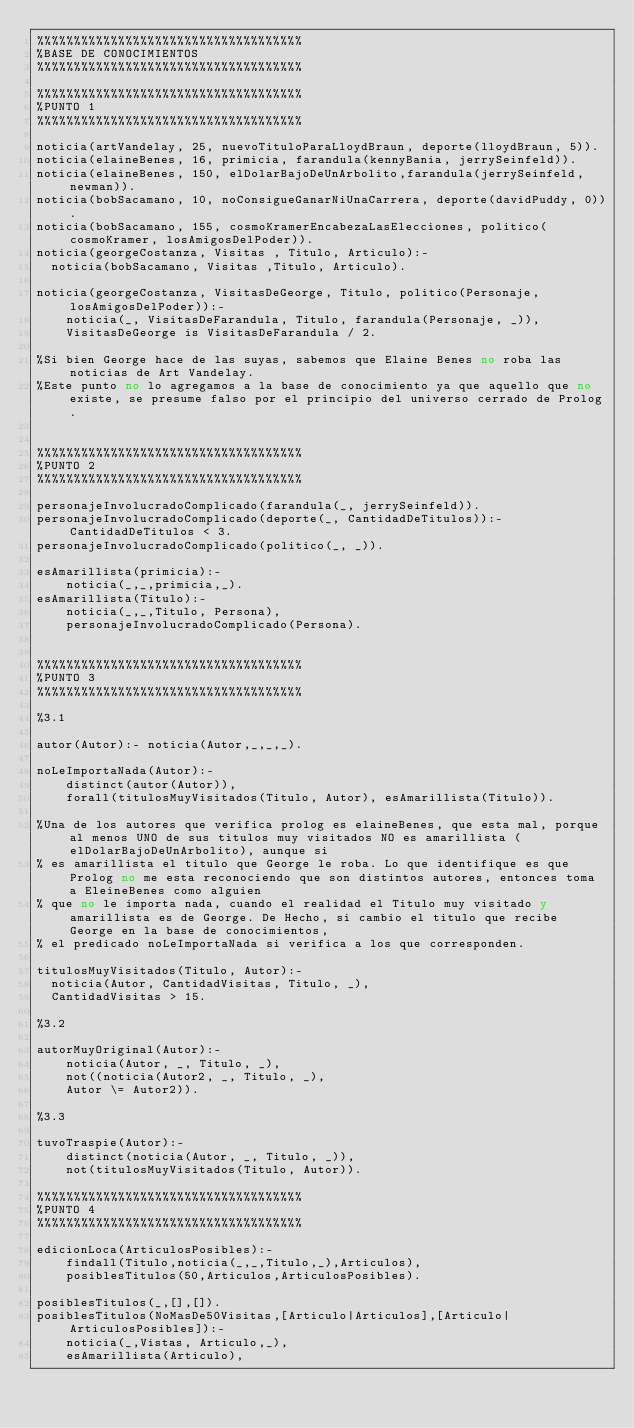<code> <loc_0><loc_0><loc_500><loc_500><_Perl_>%%%%%%%%%%%%%%%%%%%%%%%%%%%%%%%%%%%%
%BASE DE CONOCIMIENTOS
%%%%%%%%%%%%%%%%%%%%%%%%%%%%%%%%%%%%

%%%%%%%%%%%%%%%%%%%%%%%%%%%%%%%%%%%%
%PUNTO 1
%%%%%%%%%%%%%%%%%%%%%%%%%%%%%%%%%%%%

noticia(artVandelay, 25, nuevoTituloParaLloydBraun, deporte(lloydBraun, 5)).
noticia(elaineBenes, 16, primicia, farandula(kennyBania, jerrySeinfeld)).
noticia(elaineBenes, 150, elDolarBajoDeUnArbolito,farandula(jerrySeinfeld, newman)).
noticia(bobSacamano, 10, noConsigueGanarNiUnaCarrera, deporte(davidPuddy, 0)).
noticia(bobSacamano, 155, cosmoKramerEncabezaLasElecciones, politico(cosmoKramer, losAmigosDelPoder)).
noticia(georgeCostanza, Visitas , Titulo, Articulo):- 
  noticia(bobSacamano, Visitas ,Titulo, Articulo).

noticia(georgeCostanza, VisitasDeGeorge, Titulo, politico(Personaje, losAmigosDelPoder)):- 
	noticia(_, VisitasDeFarandula, Titulo, farandula(Personaje, _)), 
	VisitasDeGeorge is VisitasDeFarandula / 2.

%Si bien George hace de las suyas, sabemos que Elaine Benes no roba las noticias de Art Vandelay. 
%Este punto no lo agregamos a la base de conocimiento ya que aquello que no existe, se presume falso por el principio del universo cerrado de Prolog.


%%%%%%%%%%%%%%%%%%%%%%%%%%%%%%%%%%%%
%PUNTO 2
%%%%%%%%%%%%%%%%%%%%%%%%%%%%%%%%%%%%

personajeInvolucradoComplicado(farandula(_, jerrySeinfeld)).
personajeInvolucradoComplicado(deporte(_, CantidadDeTitulos)):- CantidadDeTitulos < 3.
personajeInvolucradoComplicado(politico(_, _)).

esAmarillista(primicia):- 
	noticia(_,_,primicia,_).
esAmarillista(Titulo):- 
	noticia(_,_,Titulo, Persona),
	personajeInvolucradoComplicado(Persona).


%%%%%%%%%%%%%%%%%%%%%%%%%%%%%%%%%%%%
%PUNTO 3
%%%%%%%%%%%%%%%%%%%%%%%%%%%%%%%%%%%%

%3.1

autor(Autor):- noticia(Autor,_,_,_).

noLeImportaNada(Autor):-
	distinct(autor(Autor)),
	forall(titulosMuyVisitados(Titulo, Autor), esAmarillista(Titulo)).

%Una de los autores que verifica prolog es elaineBenes, que esta mal, porque al menos UNO de sus titulos muy visitados NO es amarillista (elDolarBajoDeUnArbolito), aunque si
% es amarillista el titulo que George le roba. Lo que identifique es que Prolog no me esta reconociendo que son distintos autores, entonces toma a EleineBenes como alguien
% que no le importa nada, cuando el realidad el Titulo muy visitado y amarillista es de George. De Hecho, si cambio el titulo que recibe George en la base de conocimientos, 
% el predicado noLeImportaNada si verifica a los que corresponden.

titulosMuyVisitados(Titulo, Autor):- 
  noticia(Autor, CantidadVisitas, Titulo, _),
  CantidadVisitas > 15.

%3.2

autorMuyOriginal(Autor):-
	noticia(Autor, _, Titulo, _),
	not((noticia(Autor2, _, Titulo, _),
    Autor \= Autor2)).

%3.3

tuvoTraspie(Autor):- 
	distinct(noticia(Autor, _, Titulo, _)),
	not(titulosMuyVisitados(Titulo, Autor)).

%%%%%%%%%%%%%%%%%%%%%%%%%%%%%%%%%%%%
%PUNTO 4
%%%%%%%%%%%%%%%%%%%%%%%%%%%%%%%%%%%%

edicionLoca(ArticulosPosibles):- 
	findall(Titulo,noticia(_,_,Titulo,_),Articulos),
	posiblesTitulos(50,Articulos,ArticulosPosibles).
  
posiblesTitulos(_,[],[]).
posiblesTitulos(NoMasDe50Visitas,[Articulo|Articulos],[Articulo|ArticulosPosibles]):-
	noticia(_,Vistas, Articulo,_),
	esAmarillista(Articulo),</code> 